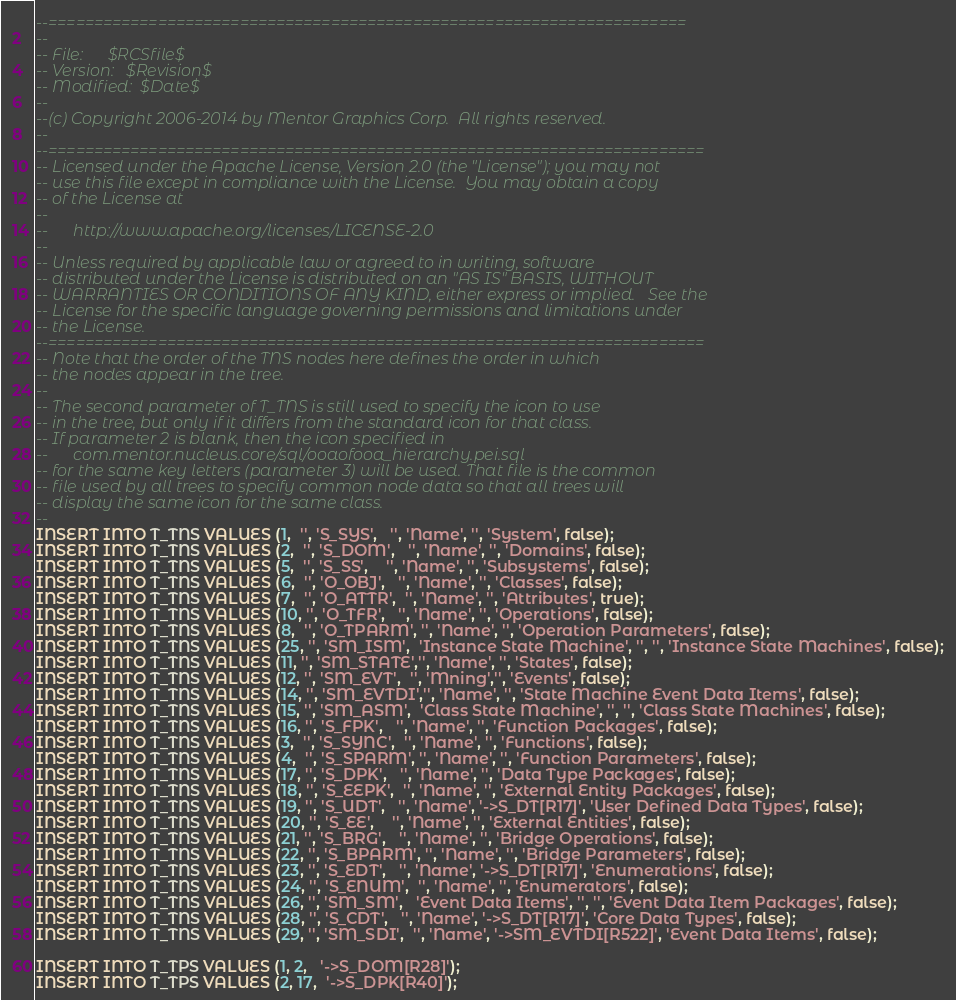<code> <loc_0><loc_0><loc_500><loc_500><_SQL_>--======================================================================
--
-- File:      $RCSfile$
-- Version:   $Revision$
-- Modified:  $Date$
--
--(c) Copyright 2006-2014 by Mentor Graphics Corp.  All rights reserved.
--
--========================================================================
-- Licensed under the Apache License, Version 2.0 (the "License"); you may not
-- use this file except in compliance with the License.  You may obtain a copy
-- of the License at
--
--      http://www.apache.org/licenses/LICENSE-2.0
--
-- Unless required by applicable law or agreed to in writing, software
-- distributed under the License is distributed on an "AS IS" BASIS, WITHOUT
-- WARRANTIES OR CONDITIONS OF ANY KIND, either express or implied.   See the
-- License for the specific language governing permissions and limitations under
-- the License.
--======================================================================== 
-- Note that the order of the TNS nodes here defines the order in which
-- the nodes appear in the tree.
--
-- The second parameter of T_TNS is still used to specify the icon to use
-- in the tree, but only if it differs from the standard icon for that class.
-- If parameter 2 is blank, then the icon specified in
--      com.mentor.nucleus.core/sql/ooaofooa_hierarchy.pei.sql
-- for the same key letters (parameter 3) will be used. That file is the common
-- file used by all trees to specify common node data so that all trees will
-- display the same icon for the same class.
--
INSERT INTO T_TNS VALUES (1,  '', 'S_SYS',   '', 'Name', '', 'System', false);
INSERT INTO T_TNS VALUES (2,  '', 'S_DOM',   '', 'Name', '', 'Domains', false);
INSERT INTO T_TNS VALUES (5,  '', 'S_SS',    '', 'Name', '', 'Subsystems', false);
INSERT INTO T_TNS VALUES (6,  '', 'O_OBJ',   '', 'Name', '', 'Classes', false);
INSERT INTO T_TNS VALUES (7,  '', 'O_ATTR',  '', 'Name', '', 'Attributes', true);
INSERT INTO T_TNS VALUES (10, '', 'O_TFR',   '', 'Name', '', 'Operations', false);
INSERT INTO T_TNS VALUES (8,  '', 'O_TPARM', '', 'Name', '', 'Operation Parameters', false);
INSERT INTO T_TNS VALUES (25, '', 'SM_ISM',  'Instance State Machine', '', '', 'Instance State Machines', false);
INSERT INTO T_TNS VALUES (11, '', 'SM_STATE','', 'Name', '', 'States', false);
INSERT INTO T_TNS VALUES (12, '', 'SM_EVT',  '', 'Mning','', 'Events', false);
INSERT INTO T_TNS VALUES (14, '', 'SM_EVTDI','', 'Name', '', 'State Machine Event Data Items', false);
INSERT INTO T_TNS VALUES (15, '', 'SM_ASM',  'Class State Machine', '', '', 'Class State Machines', false);
INSERT INTO T_TNS VALUES (16, '', 'S_FPK',   '', 'Name', '', 'Function Packages', false);
INSERT INTO T_TNS VALUES (3,  '', 'S_SYNC',  '', 'Name', '', 'Functions', false);
INSERT INTO T_TNS VALUES (4,  '', 'S_SPARM', '', 'Name', '', 'Function Parameters', false);
INSERT INTO T_TNS VALUES (17, '', 'S_DPK',   '', 'Name', '', 'Data Type Packages', false);
INSERT INTO T_TNS VALUES (18, '', 'S_EEPK',  '', 'Name', '', 'External Entity Packages', false);
INSERT INTO T_TNS VALUES (19, '', 'S_UDT',   '', 'Name', '->S_DT[R17]', 'User Defined Data Types', false);
INSERT INTO T_TNS VALUES (20, '', 'S_EE',    '', 'Name', '', 'External Entities', false);
INSERT INTO T_TNS VALUES (21, '', 'S_BRG',   '', 'Name', '', 'Bridge Operations', false);
INSERT INTO T_TNS VALUES (22, '', 'S_BPARM', '', 'Name', '', 'Bridge Parameters', false);
INSERT INTO T_TNS VALUES (23, '', 'S_EDT',   '', 'Name', '->S_DT[R17]', 'Enumerations', false);
INSERT INTO T_TNS VALUES (24, '', 'S_ENUM',  '', 'Name', '', 'Enumerators', false);
INSERT INTO T_TNS VALUES (26, '', 'SM_SM',   'Event Data Items', '', '', 'Event Data Item Packages', false);
INSERT INTO T_TNS VALUES (28, '', 'S_CDT',   '', 'Name', '->S_DT[R17]', 'Core Data Types', false);
INSERT INTO T_TNS VALUES (29, '', 'SM_SDI',  '', 'Name', '->SM_EVTDI[R522]', 'Event Data Items', false);

INSERT INTO T_TPS VALUES (1, 2,   '->S_DOM[R28]');
INSERT INTO T_TPS VALUES (2, 17,  '->S_DPK[R40]');</code> 